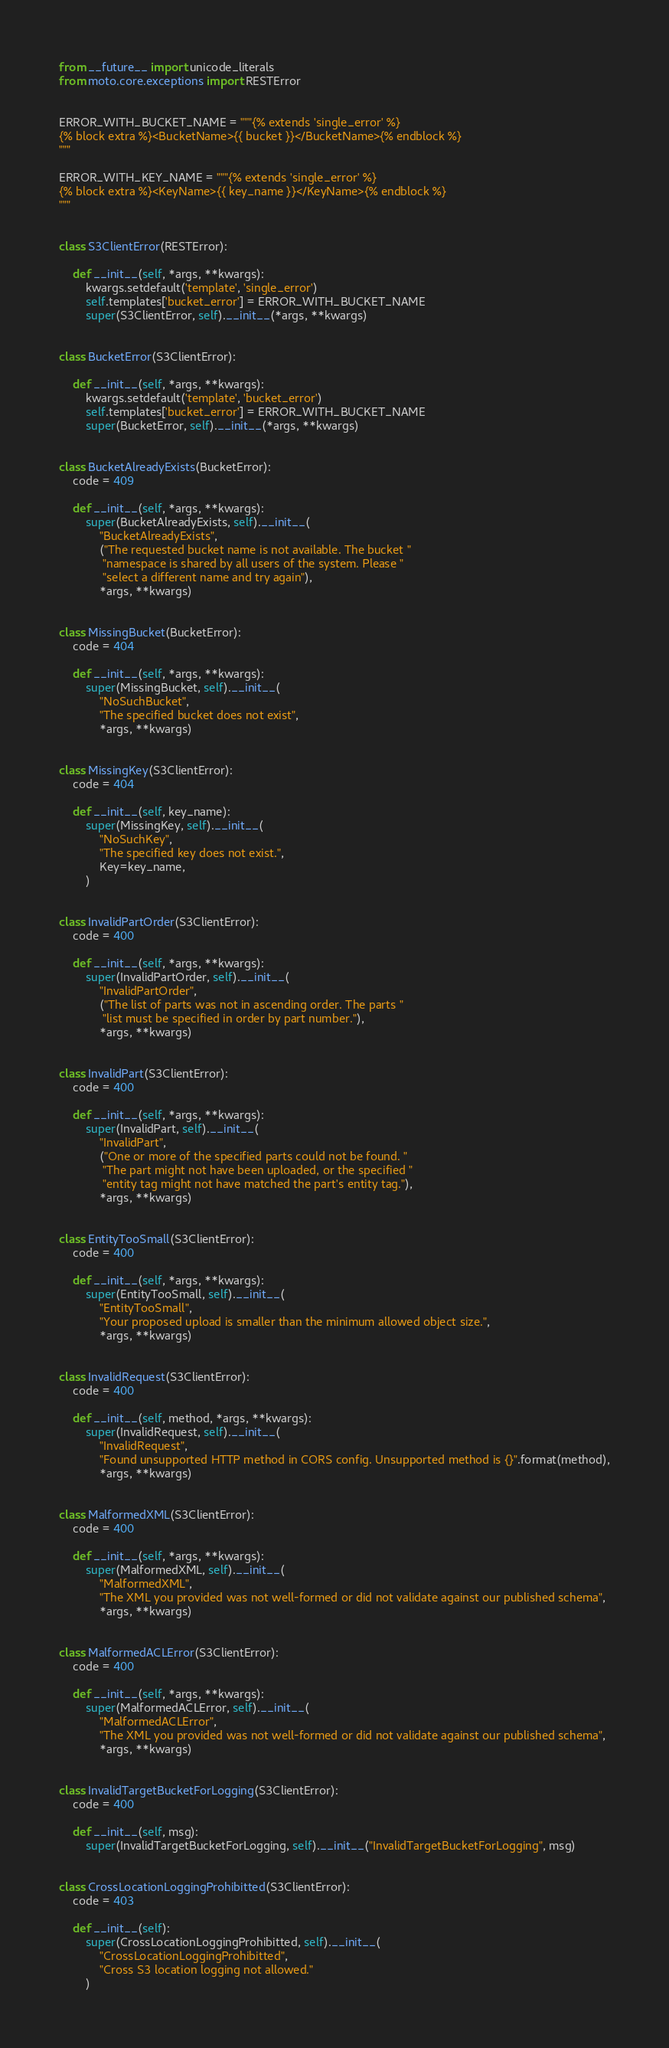Convert code to text. <code><loc_0><loc_0><loc_500><loc_500><_Python_>from __future__ import unicode_literals
from moto.core.exceptions import RESTError


ERROR_WITH_BUCKET_NAME = """{% extends 'single_error' %}
{% block extra %}<BucketName>{{ bucket }}</BucketName>{% endblock %}
"""

ERROR_WITH_KEY_NAME = """{% extends 'single_error' %}
{% block extra %}<KeyName>{{ key_name }}</KeyName>{% endblock %}
"""


class S3ClientError(RESTError):

    def __init__(self, *args, **kwargs):
        kwargs.setdefault('template', 'single_error')
        self.templates['bucket_error'] = ERROR_WITH_BUCKET_NAME
        super(S3ClientError, self).__init__(*args, **kwargs)


class BucketError(S3ClientError):

    def __init__(self, *args, **kwargs):
        kwargs.setdefault('template', 'bucket_error')
        self.templates['bucket_error'] = ERROR_WITH_BUCKET_NAME
        super(BucketError, self).__init__(*args, **kwargs)


class BucketAlreadyExists(BucketError):
    code = 409

    def __init__(self, *args, **kwargs):
        super(BucketAlreadyExists, self).__init__(
            "BucketAlreadyExists",
            ("The requested bucket name is not available. The bucket "
             "namespace is shared by all users of the system. Please "
             "select a different name and try again"),
            *args, **kwargs)


class MissingBucket(BucketError):
    code = 404

    def __init__(self, *args, **kwargs):
        super(MissingBucket, self).__init__(
            "NoSuchBucket",
            "The specified bucket does not exist",
            *args, **kwargs)


class MissingKey(S3ClientError):
    code = 404

    def __init__(self, key_name):
        super(MissingKey, self).__init__(
            "NoSuchKey",
            "The specified key does not exist.",
            Key=key_name,
        )


class InvalidPartOrder(S3ClientError):
    code = 400

    def __init__(self, *args, **kwargs):
        super(InvalidPartOrder, self).__init__(
            "InvalidPartOrder",
            ("The list of parts was not in ascending order. The parts "
             "list must be specified in order by part number."),
            *args, **kwargs)


class InvalidPart(S3ClientError):
    code = 400

    def __init__(self, *args, **kwargs):
        super(InvalidPart, self).__init__(
            "InvalidPart",
            ("One or more of the specified parts could not be found. "
             "The part might not have been uploaded, or the specified "
             "entity tag might not have matched the part's entity tag."),
            *args, **kwargs)


class EntityTooSmall(S3ClientError):
    code = 400

    def __init__(self, *args, **kwargs):
        super(EntityTooSmall, self).__init__(
            "EntityTooSmall",
            "Your proposed upload is smaller than the minimum allowed object size.",
            *args, **kwargs)


class InvalidRequest(S3ClientError):
    code = 400

    def __init__(self, method, *args, **kwargs):
        super(InvalidRequest, self).__init__(
            "InvalidRequest",
            "Found unsupported HTTP method in CORS config. Unsupported method is {}".format(method),
            *args, **kwargs)


class MalformedXML(S3ClientError):
    code = 400

    def __init__(self, *args, **kwargs):
        super(MalformedXML, self).__init__(
            "MalformedXML",
            "The XML you provided was not well-formed or did not validate against our published schema",
            *args, **kwargs)


class MalformedACLError(S3ClientError):
    code = 400

    def __init__(self, *args, **kwargs):
        super(MalformedACLError, self).__init__(
            "MalformedACLError",
            "The XML you provided was not well-formed or did not validate against our published schema",
            *args, **kwargs)


class InvalidTargetBucketForLogging(S3ClientError):
    code = 400

    def __init__(self, msg):
        super(InvalidTargetBucketForLogging, self).__init__("InvalidTargetBucketForLogging", msg)


class CrossLocationLoggingProhibitted(S3ClientError):
    code = 403

    def __init__(self):
        super(CrossLocationLoggingProhibitted, self).__init__(
            "CrossLocationLoggingProhibitted",
            "Cross S3 location logging not allowed."
        )
</code> 